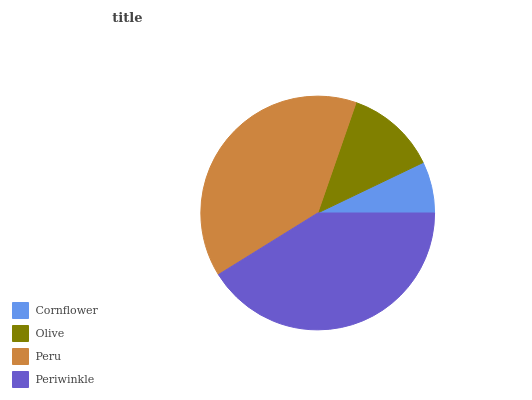Is Cornflower the minimum?
Answer yes or no. Yes. Is Periwinkle the maximum?
Answer yes or no. Yes. Is Olive the minimum?
Answer yes or no. No. Is Olive the maximum?
Answer yes or no. No. Is Olive greater than Cornflower?
Answer yes or no. Yes. Is Cornflower less than Olive?
Answer yes or no. Yes. Is Cornflower greater than Olive?
Answer yes or no. No. Is Olive less than Cornflower?
Answer yes or no. No. Is Peru the high median?
Answer yes or no. Yes. Is Olive the low median?
Answer yes or no. Yes. Is Cornflower the high median?
Answer yes or no. No. Is Peru the low median?
Answer yes or no. No. 